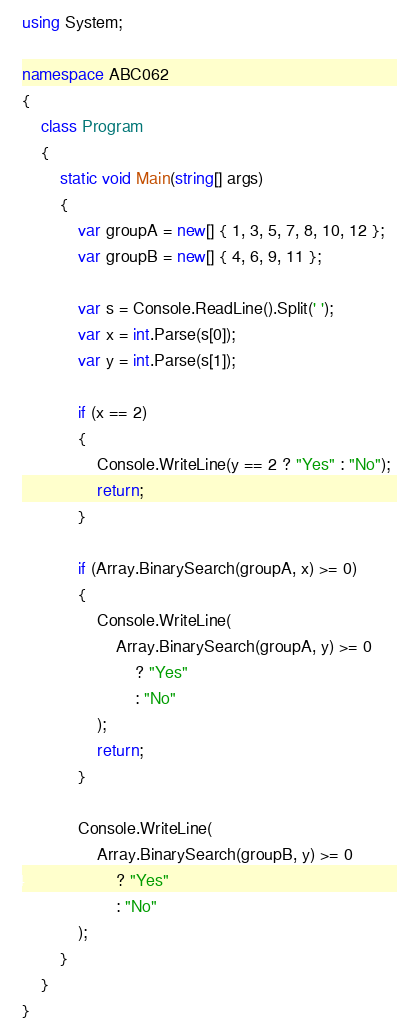Convert code to text. <code><loc_0><loc_0><loc_500><loc_500><_C#_>using System;

namespace ABC062
{
    class Program
    {
        static void Main(string[] args)
        {
            var groupA = new[] { 1, 3, 5, 7, 8, 10, 12 };
            var groupB = new[] { 4, 6, 9, 11 };

            var s = Console.ReadLine().Split(' ');
            var x = int.Parse(s[0]);
            var y = int.Parse(s[1]);

            if (x == 2)
            {
                Console.WriteLine(y == 2 ? "Yes" : "No");
                return;
            }

            if (Array.BinarySearch(groupA, x) >= 0)
            {
                Console.WriteLine(
                    Array.BinarySearch(groupA, y) >= 0
                        ? "Yes"
                        : "No"
                );
                return;
            }

            Console.WriteLine(
                Array.BinarySearch(groupB, y) >= 0
                    ? "Yes"
                    : "No"
            );
        }
    }
}
</code> 